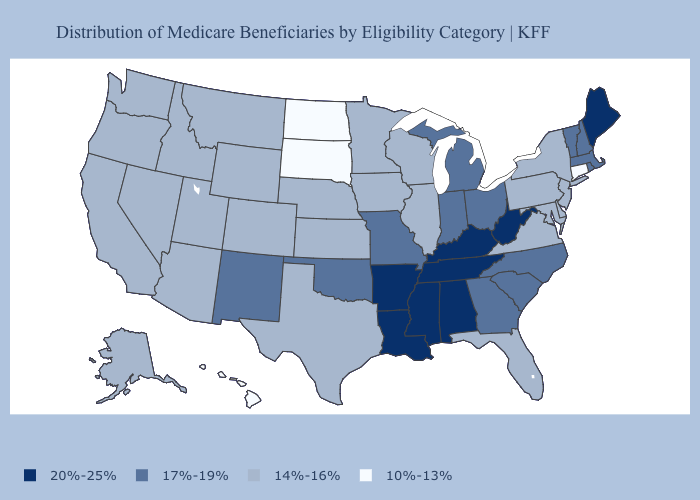What is the value of Iowa?
Concise answer only. 14%-16%. Which states hav the highest value in the West?
Give a very brief answer. New Mexico. What is the value of Wyoming?
Be succinct. 14%-16%. What is the highest value in the USA?
Answer briefly. 20%-25%. What is the value of Indiana?
Give a very brief answer. 17%-19%. What is the lowest value in states that border New York?
Concise answer only. 10%-13%. Which states hav the highest value in the Northeast?
Give a very brief answer. Maine. Does Michigan have the highest value in the USA?
Concise answer only. No. What is the value of Alabama?
Answer briefly. 20%-25%. What is the lowest value in the Northeast?
Answer briefly. 10%-13%. What is the value of Nevada?
Quick response, please. 14%-16%. Name the states that have a value in the range 17%-19%?
Concise answer only. Georgia, Indiana, Massachusetts, Michigan, Missouri, New Hampshire, New Mexico, North Carolina, Ohio, Oklahoma, Rhode Island, South Carolina, Vermont. Among the states that border Wyoming , does South Dakota have the highest value?
Short answer required. No. Name the states that have a value in the range 20%-25%?
Answer briefly. Alabama, Arkansas, Kentucky, Louisiana, Maine, Mississippi, Tennessee, West Virginia. What is the highest value in the USA?
Be succinct. 20%-25%. 